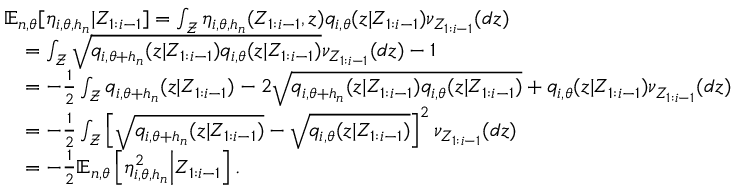Convert formula to latex. <formula><loc_0><loc_0><loc_500><loc_500>\begin{array} { r l } & { { \mathbb { E } } _ { n , \theta } [ \eta _ { i , \theta , h _ { n } } | Z _ { 1 \colon i - 1 } ] = \int _ { \mathcal { Z } } \eta _ { i , \theta , h _ { n } } ( Z _ { 1 \colon i - 1 } , z ) q _ { i , \theta } ( z | Z _ { 1 \colon i - 1 } ) \nu _ { Z _ { 1 \colon i - 1 } } ( d z ) } \\ & { \quad = \int _ { \mathcal { Z } } \sqrt { q _ { i , \theta + h _ { n } } ( z | Z _ { 1 \colon i - 1 } ) q _ { i , \theta } ( z | Z _ { 1 \colon i - 1 } ) } \nu _ { Z _ { 1 \colon i - 1 } } ( d z ) - 1 } \\ & { \quad = - \frac { 1 } { 2 } \int _ { \mathcal { Z } } q _ { i , \theta + h _ { n } } ( z | Z _ { 1 \colon i - 1 } ) - 2 \sqrt { q _ { i , \theta + h _ { n } } ( z | Z _ { 1 \colon i - 1 } ) q _ { i , \theta } ( z | Z _ { 1 \colon i - 1 } ) } + q _ { i , \theta } ( z | Z _ { 1 \colon i - 1 } ) \nu _ { Z _ { 1 \colon i - 1 } } ( d z ) } \\ & { \quad = - \frac { 1 } { 2 } \int _ { \mathcal { Z } } \left [ \sqrt { q _ { i , \theta + h _ { n } } ( z | Z _ { 1 \colon i - 1 } ) } - \sqrt { q _ { i , \theta } ( z | Z _ { 1 \colon i - 1 } ) } \right ] ^ { 2 } \nu _ { Z _ { 1 \colon i - 1 } } ( d z ) } \\ & { \quad = - \frac { 1 } { 2 } { \mathbb { E } } _ { n , \theta } \left [ \eta _ { i , \theta , h _ { n } } ^ { 2 } \Big | Z _ { 1 \colon i - 1 } \right ] . } \end{array}</formula> 